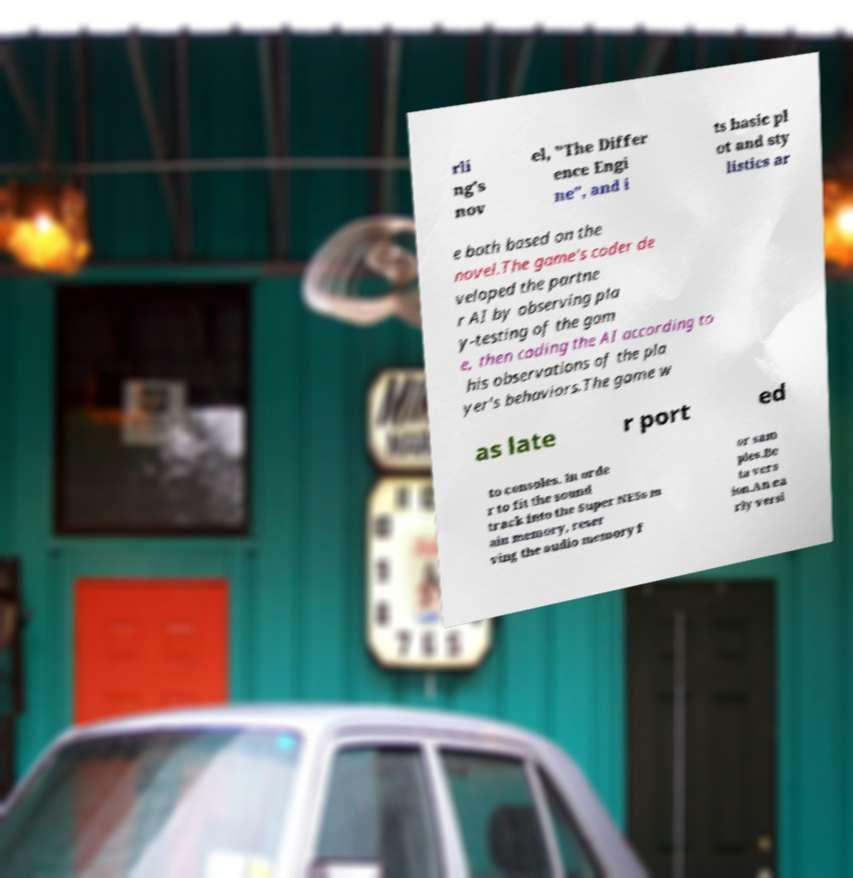Please identify and transcribe the text found in this image. rli ng's nov el, "The Differ ence Engi ne", and i ts basic pl ot and sty listics ar e both based on the novel.The game's coder de veloped the partne r AI by observing pla y-testing of the gam e, then coding the AI according to his observations of the pla yer's behaviors.The game w as late r port ed to consoles. In orde r to fit the sound track into the Super NESs m ain memory, reser ving the audio memory f or sam ples.Be ta vers ion.An ea rly versi 